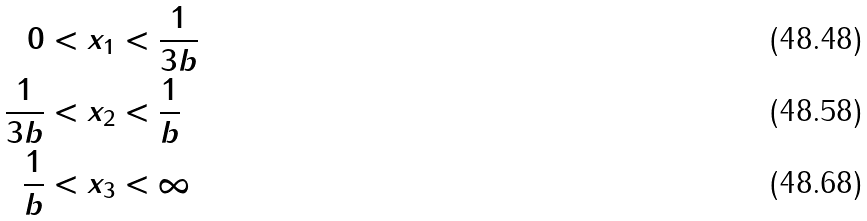Convert formula to latex. <formula><loc_0><loc_0><loc_500><loc_500>0 & < x _ { 1 } < \frac { 1 } { 3 b } \\ \frac { 1 } { 3 b } & < x _ { 2 } < \frac { 1 } { b } \\ \frac { 1 } { b } & < x _ { 3 } < \infty</formula> 